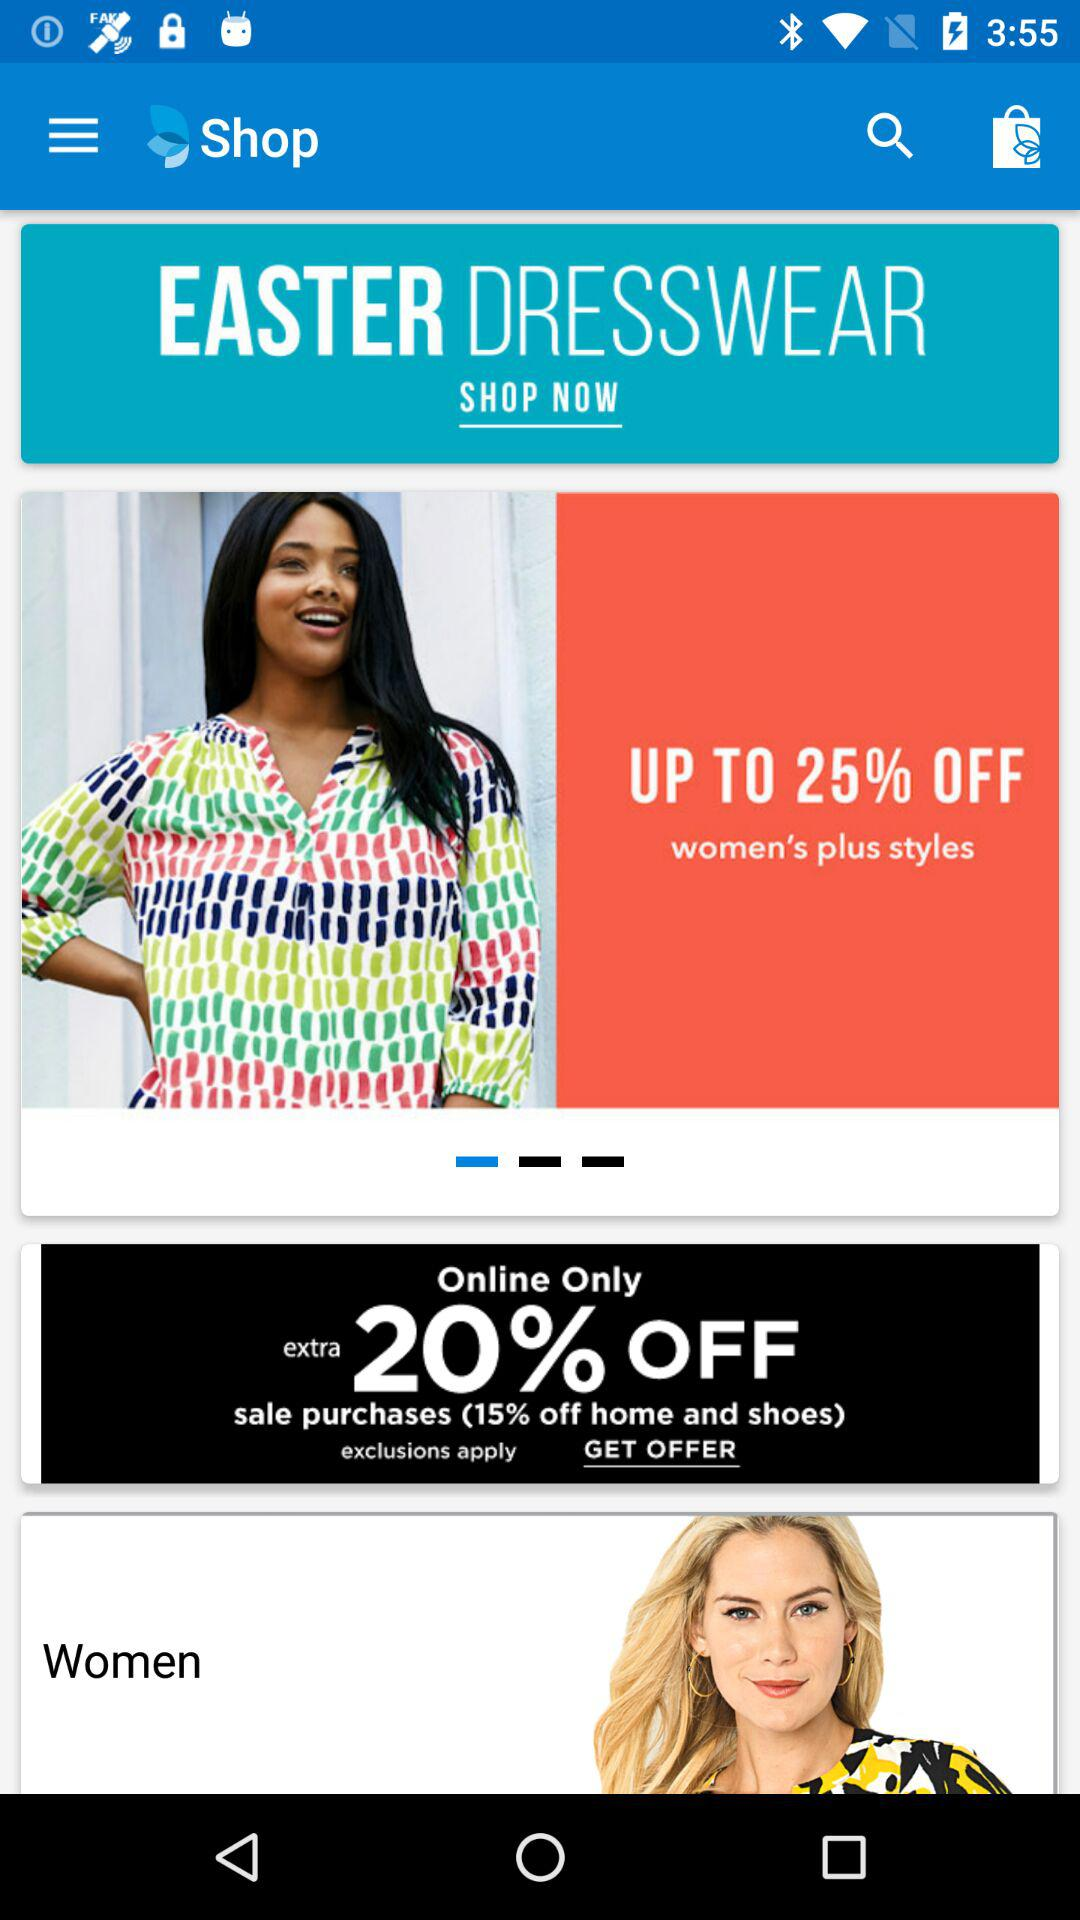What is the off percentage on women's plus styles? The off percentage on women's plus styles is up to 25. 